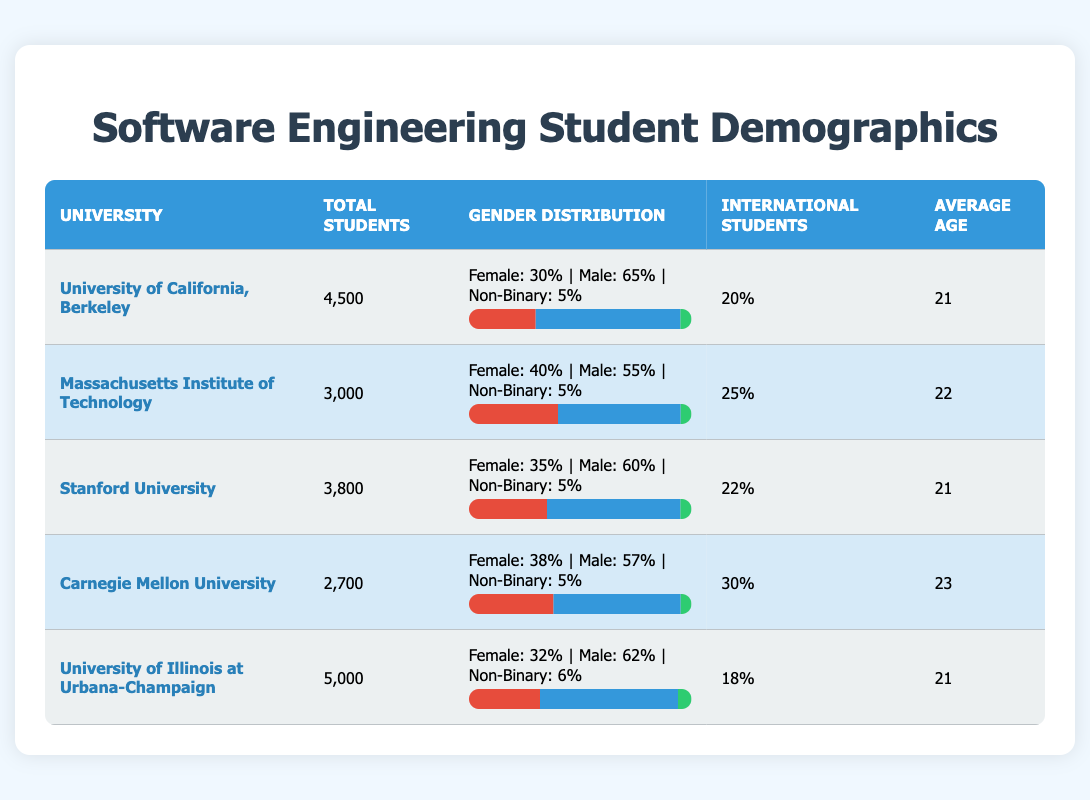What is the total number of students at Stanford University? The table shows that Stanford University has a total of 3,800 students listed under the "Total Students" column.
Answer: 3,800 Which university has the highest percentage of undergraduate female students? By examining the "Undergraduate Female Percentage" column, Massachusetts Institute of Technology has the highest percentage at 40%.
Answer: Massachusetts Institute of Technology What is the average age of students at Carnegie Mellon University? The table states the average age for Carnegie Mellon University students, which is listed as 23.
Answer: 23 Is the percentage of international students at University of Illinois at Urbana-Champaign greater than at Stanford University? The international student percentages show 18% for the University of Illinois at Urbana-Champaign and 22% for Stanford University. Since 18% is less than 22%, it is false that Illinois has a greater percentage.
Answer: No What is the combined total of undergraduate male students from University of California, Berkeley, and University of Illinois at Urbana-Champaign? The undergraduate male percentages are 65% for Berkeley and 62% for Illinois. To find the combined total, we first calculate their individual values: 65% of 4500 = 2925 and 62% of 5000 = 3100. Adding these gives us 2925 + 3100 = 6025.
Answer: 6,025 Which university has a higher percentage of non-binary students: University of California, Berkeley or Carnegie Mellon University? The non-binary percentages are 5% for UC Berkeley and 5% for Carnegie Mellon University. Since both percentages are equal, it is true that neither has a greater percentage.
Answer: They are equal 